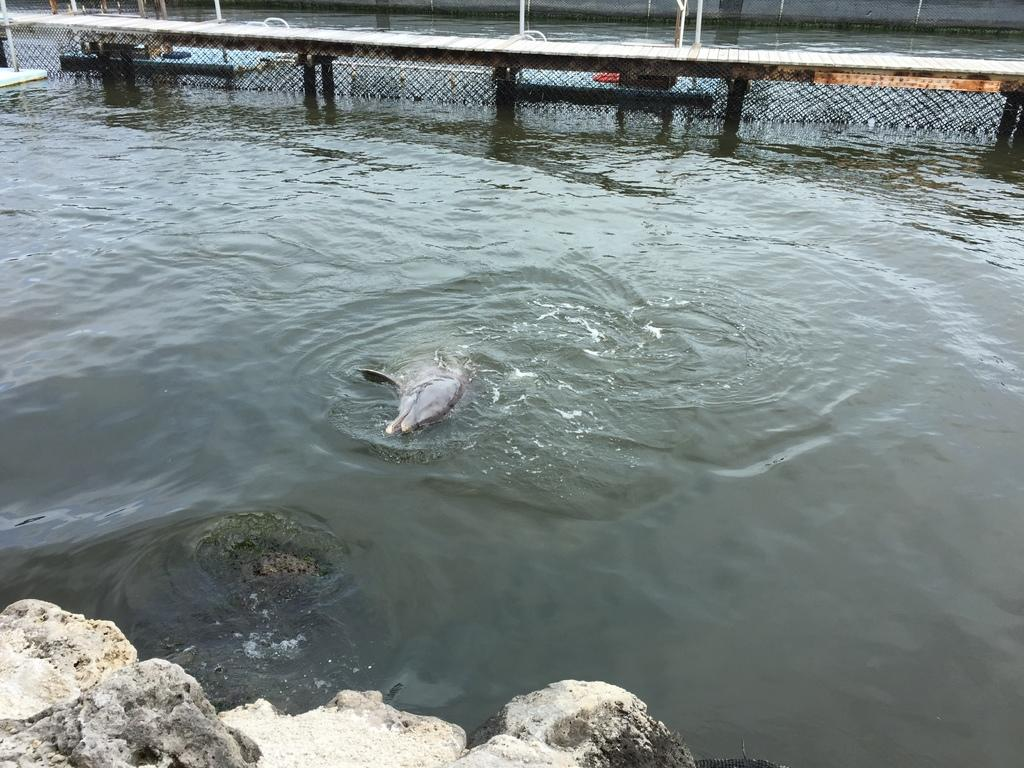What is the primary element in the image? There is water in the image. What can be seen in the water? There is an animal in the water. What is at the bottom of the image? There are rocks at the bottom of the image. What structure is visible at the top of the image? There is a bridge with mesh and pillars at the top of the image. What type of thread is being used to create the animal's fur in the image? There is no thread present in the image, and the animal's fur is not created using thread. 